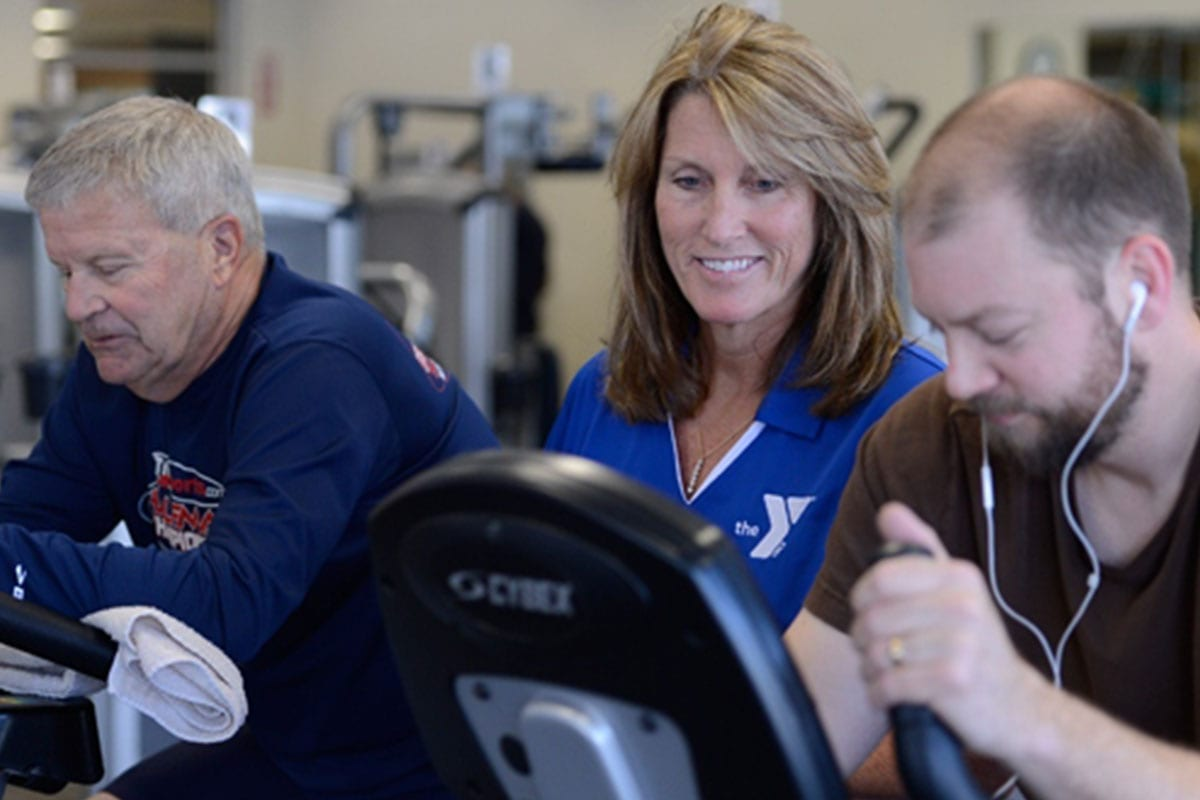Imagine the instructor decided to organize a fun and creative activity using the exercise equipment, what could it be? The instructor might organize a 'Cycling Marathon' with a virtual tour feature. Participants would cycle through different sceneries projected onto a screen, such as the streets of Paris, the landscapes of New Zealand, or the beaches of Hawaii. The instructor could integrate music, storytelling, and challenges to make the experience immersive and engaging. For example, as the group virtually cycles through the mountains, they could encounter 'uphill' intervals where they need to increase the resistance, or 'downhill' segments where they can speed up. This type of activity would not only make the workout enjoyable but also add an element of adventure and variety to the exercise routine. 